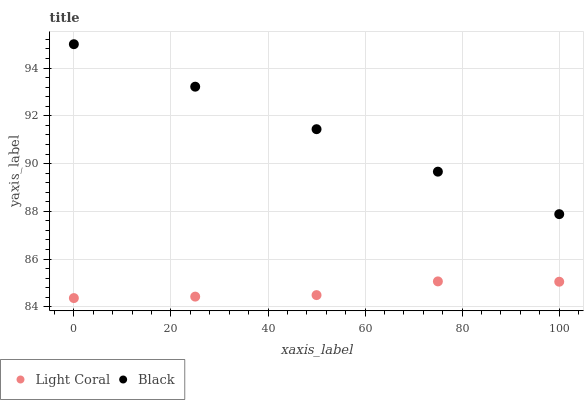Does Light Coral have the minimum area under the curve?
Answer yes or no. Yes. Does Black have the maximum area under the curve?
Answer yes or no. Yes. Does Black have the minimum area under the curve?
Answer yes or no. No. Is Black the smoothest?
Answer yes or no. Yes. Is Light Coral the roughest?
Answer yes or no. Yes. Is Black the roughest?
Answer yes or no. No. Does Light Coral have the lowest value?
Answer yes or no. Yes. Does Black have the lowest value?
Answer yes or no. No. Does Black have the highest value?
Answer yes or no. Yes. Is Light Coral less than Black?
Answer yes or no. Yes. Is Black greater than Light Coral?
Answer yes or no. Yes. Does Light Coral intersect Black?
Answer yes or no. No. 